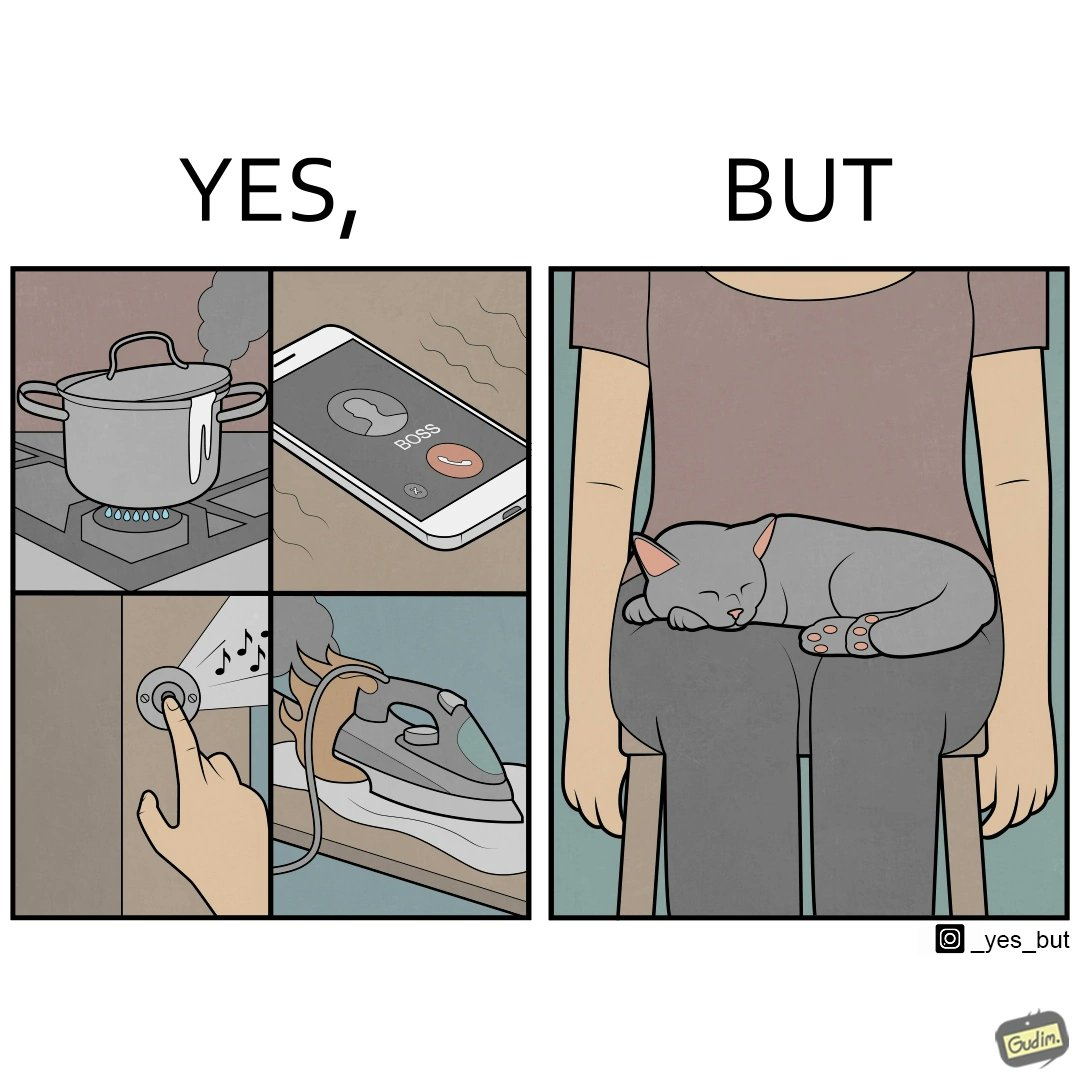Why is this image considered satirical? the irony in this image is that people ignore all the chaos around them and get distracted by a cat. 